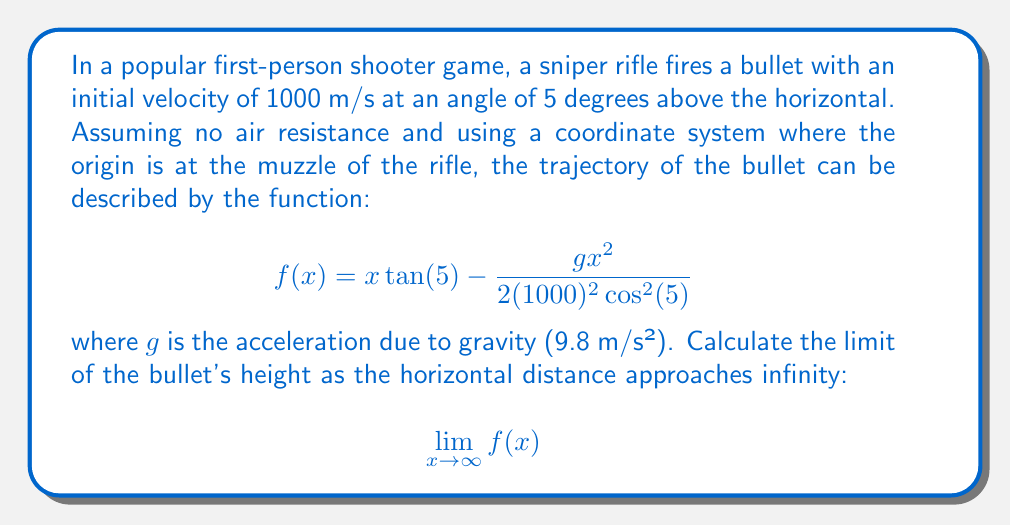Help me with this question. Let's approach this step-by-step:

1) First, let's simplify the function by substituting known values:
   
   $\tan(5°) \approx 0.0875$
   $\cos^2(5°) \approx 0.9924$
   $g = 9.8$ m/s²

   $$f(x) = 0.0875x - \frac{9.8x^2}{2(1000)^2(0.9924)}$$

2) Simplify further:
   
   $$f(x) = 0.0875x - 0.00000494x^2$$

3) To find the limit as $x$ approaches infinity, we need to consider the behavior of each term:

   - The term $0.0875x$ grows linearly with $x$
   - The term $-0.00000494x^2$ grows quadratically with $x$

4) As $x$ gets very large, the quadratic term will dominate:

   $$\lim_{x \to \infty} (0.0875x - 0.00000494x^2) = \lim_{x \to \infty} (-0.00000494x^2)$$

5) The coefficient of $x^2$ is negative, so as $x$ approaches infinity, this function will approach negative infinity.

Therefore, the limit of the bullet's height as the horizontal distance approaches infinity is negative infinity. This makes sense physically, as the bullet will eventually fall below its starting point and continue to fall indefinitely (in this idealized model).
Answer: $$\lim_{x \to \infty} f(x) = -\infty$$ 